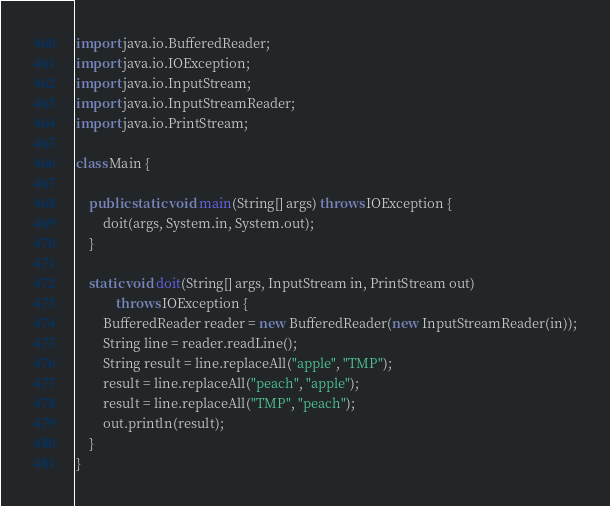Convert code to text. <code><loc_0><loc_0><loc_500><loc_500><_Java_>import java.io.BufferedReader;
import java.io.IOException;
import java.io.InputStream;
import java.io.InputStreamReader;
import java.io.PrintStream;

class Main {

    public static void main(String[] args) throws IOException {
        doit(args, System.in, System.out);
    }

    static void doit(String[] args, InputStream in, PrintStream out)
            throws IOException {
        BufferedReader reader = new BufferedReader(new InputStreamReader(in));
        String line = reader.readLine();
        String result = line.replaceAll("apple", "TMP");
        result = line.replaceAll("peach", "apple");
        result = line.replaceAll("TMP", "peach");
        out.println(result);
    }
}</code> 